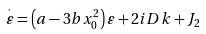Convert formula to latex. <formula><loc_0><loc_0><loc_500><loc_500>\overset { \cdot } { \varepsilon } = \left ( a - 3 b x _ { 0 } ^ { 2 } \right ) \varepsilon + 2 i D k + J _ { 2 }</formula> 